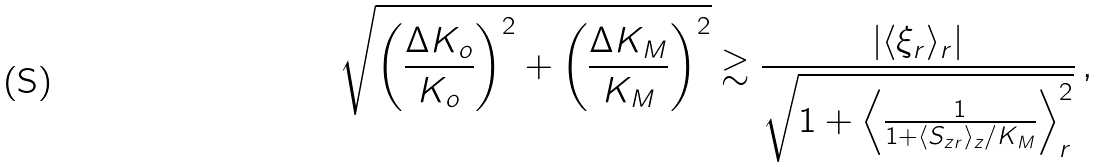Convert formula to latex. <formula><loc_0><loc_0><loc_500><loc_500>\sqrt { \left ( \frac { \Delta K _ { o } } { K _ { o } } \right ) ^ { 2 } + \left ( \frac { \Delta K _ { M } } { K _ { M } } \right ) ^ { 2 } } \gtrsim \frac { | \langle \xi _ { r } \rangle _ { r } | } { \sqrt { 1 + \left \langle \frac { 1 } { 1 + \langle S _ { z r } \rangle _ { z } / K _ { M } } \right \rangle ^ { 2 } _ { r } } } \, ,</formula> 